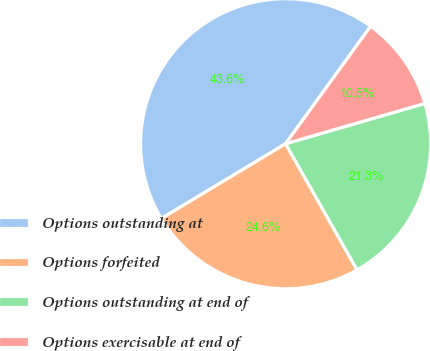Convert chart to OTSL. <chart><loc_0><loc_0><loc_500><loc_500><pie_chart><fcel>Options outstanding at<fcel>Options forfeited<fcel>Options outstanding at end of<fcel>Options exercisable at end of<nl><fcel>43.59%<fcel>24.58%<fcel>21.28%<fcel>10.54%<nl></chart> 